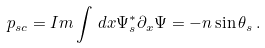Convert formula to latex. <formula><loc_0><loc_0><loc_500><loc_500>p _ { s c } = I m \int \, d x \Psi _ { s } ^ { * } \partial _ { x } \Psi = - n \sin \theta _ { s } \, .</formula> 